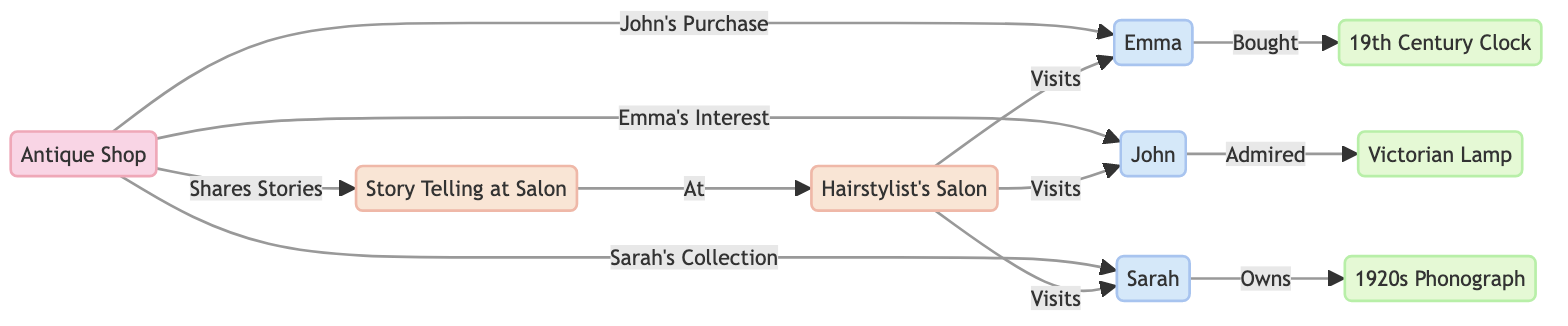What are the names of the regular customers? The diagram lists three regular customers: Emma, John, and Sarah. I can identify these names from the nodes labeled as 'Regular Customer' in the diagram.
Answer: Emma, John, Sarah How many vintage treasures are associated with the customers? There are three vintage treasures mentioned: 19th Century Clock, Victorian Lamp, and 1920s Phonograph. Each customer is linked to one treasure. Therefore, the total is three treasures.
Answer: 3 Which customer bought the 19th Century Clock? By examining the edge from the 'Regular Customer: John' node, it indicates a connection labeled 'Bought', leading to '19th Century Clock'. Therefore, John is the customer associated with this clock.
Answer: John What does the Antique Shop do with the Vintage Treasures? The Antique Shop is connected specifically to each customer through directed edges that represent different actions: John's purchase, Emma's interest, and Sarah's collection. This indicates that the Antique Shop engages with the customers regarding these treasures.
Answer: Engage with customers How are the customers connected to the hairstylist's salon? Each customer node has a directed edge to 'Hairstylist's Salon', labeled 'Visits', which shows that all three customers (Emma, John, Sarah) visit the salon. This connection illustrates the relationship between the customers and the hairstylist's salon.
Answer: They all visit the salon Which node shares stories at the salon? The 'Story Telling at Salon' node is linked to both the 'Antique Shop' and 'Hairstylist's Salon' nodes. This connection indicates that the Antique Shop shares stories at the salon while contributing to the social interaction around vintage treasures.
Answer: Story Telling at Salon How many edges are related to customer interactions? The diagram includes edges stating how each customer interacts with the vintage treasures as well as their visits to the salon. Counting these edges results in six unique connections related to customer interactions.
Answer: 6 What is the relationship between the Antique Shop and the Story Telling? The relationship is established through an edge going from the Antique Shop to Story Telling with the label 'Shares Stories'. This indicates that the Antique Shop's function includes sharing stories relevant to the customers at the salon.
Answer: Shares Stories What kind of vintage lamp does Emma admire? The edge connected to 'Regular Customer: Emma' specifies her particular interest in the node labeled 'Victorian Lamp'. Thus, it identifies that Emma admires this specific type of vintage lamp.
Answer: Victorian Lamp 